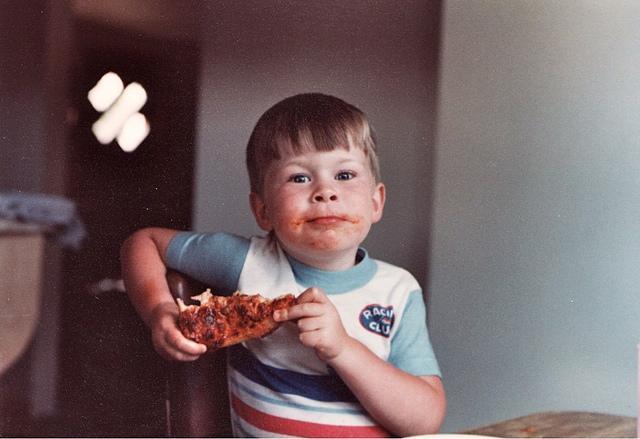Is "The pizza is touching the person." an appropriate description for the image?
Answer yes or no. Yes. 